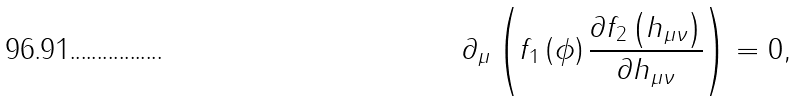<formula> <loc_0><loc_0><loc_500><loc_500>\partial _ { \mu } \left ( f _ { 1 } \left ( \phi \right ) \frac { \partial f _ { 2 } \left ( h _ { \mu \nu } \right ) } { \partial h _ { \mu \nu } } \right ) = 0 ,</formula> 